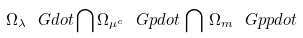Convert formula to latex. <formula><loc_0><loc_0><loc_500><loc_500>\Omega _ { \lambda } \ G d o t \bigcap \Omega _ { \mu ^ { c } } \ G p d o t \, \bigcap \, \Omega _ { m } \ G p p d o t</formula> 